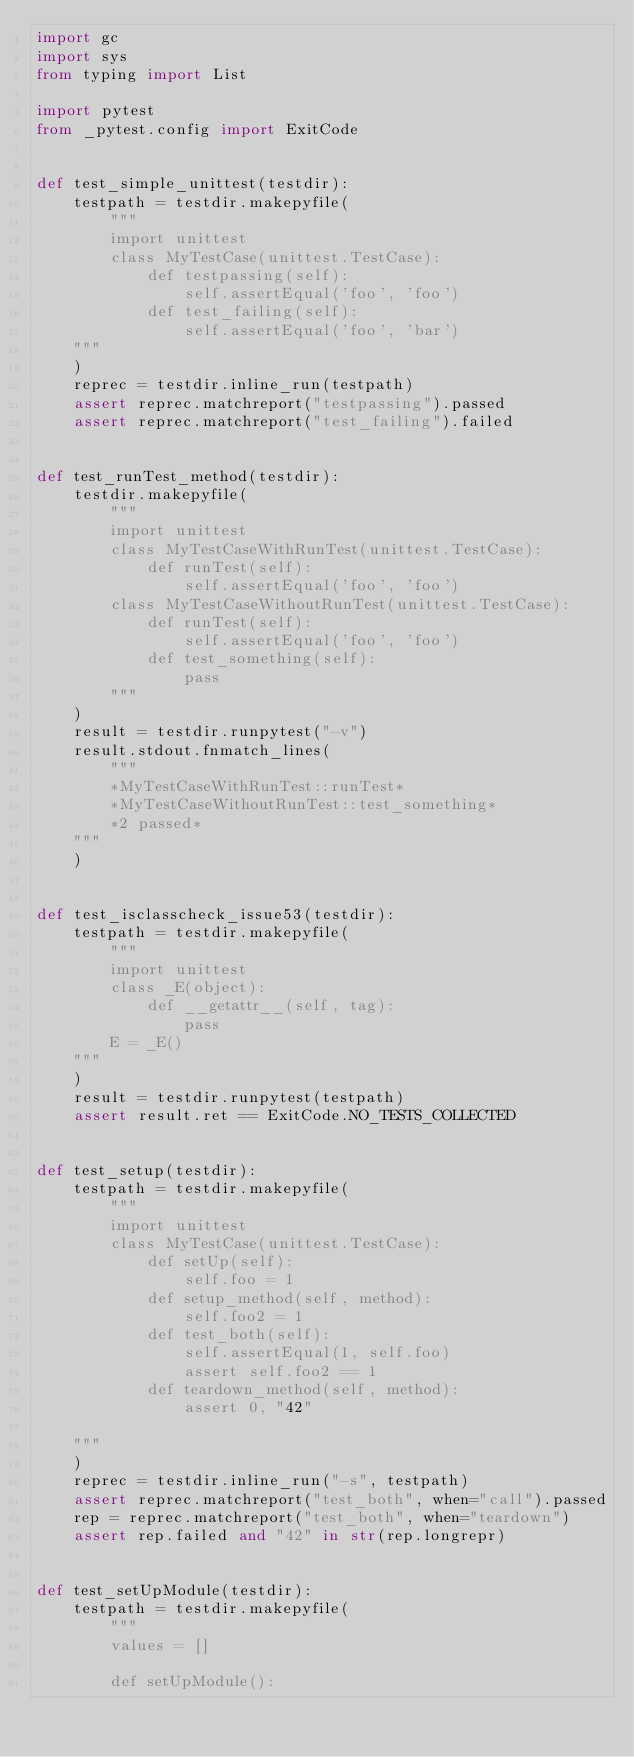<code> <loc_0><loc_0><loc_500><loc_500><_Python_>import gc
import sys
from typing import List

import pytest
from _pytest.config import ExitCode


def test_simple_unittest(testdir):
    testpath = testdir.makepyfile(
        """
        import unittest
        class MyTestCase(unittest.TestCase):
            def testpassing(self):
                self.assertEqual('foo', 'foo')
            def test_failing(self):
                self.assertEqual('foo', 'bar')
    """
    )
    reprec = testdir.inline_run(testpath)
    assert reprec.matchreport("testpassing").passed
    assert reprec.matchreport("test_failing").failed


def test_runTest_method(testdir):
    testdir.makepyfile(
        """
        import unittest
        class MyTestCaseWithRunTest(unittest.TestCase):
            def runTest(self):
                self.assertEqual('foo', 'foo')
        class MyTestCaseWithoutRunTest(unittest.TestCase):
            def runTest(self):
                self.assertEqual('foo', 'foo')
            def test_something(self):
                pass
        """
    )
    result = testdir.runpytest("-v")
    result.stdout.fnmatch_lines(
        """
        *MyTestCaseWithRunTest::runTest*
        *MyTestCaseWithoutRunTest::test_something*
        *2 passed*
    """
    )


def test_isclasscheck_issue53(testdir):
    testpath = testdir.makepyfile(
        """
        import unittest
        class _E(object):
            def __getattr__(self, tag):
                pass
        E = _E()
    """
    )
    result = testdir.runpytest(testpath)
    assert result.ret == ExitCode.NO_TESTS_COLLECTED


def test_setup(testdir):
    testpath = testdir.makepyfile(
        """
        import unittest
        class MyTestCase(unittest.TestCase):
            def setUp(self):
                self.foo = 1
            def setup_method(self, method):
                self.foo2 = 1
            def test_both(self):
                self.assertEqual(1, self.foo)
                assert self.foo2 == 1
            def teardown_method(self, method):
                assert 0, "42"

    """
    )
    reprec = testdir.inline_run("-s", testpath)
    assert reprec.matchreport("test_both", when="call").passed
    rep = reprec.matchreport("test_both", when="teardown")
    assert rep.failed and "42" in str(rep.longrepr)


def test_setUpModule(testdir):
    testpath = testdir.makepyfile(
        """
        values = []

        def setUpModule():</code> 